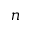<formula> <loc_0><loc_0><loc_500><loc_500>n</formula> 